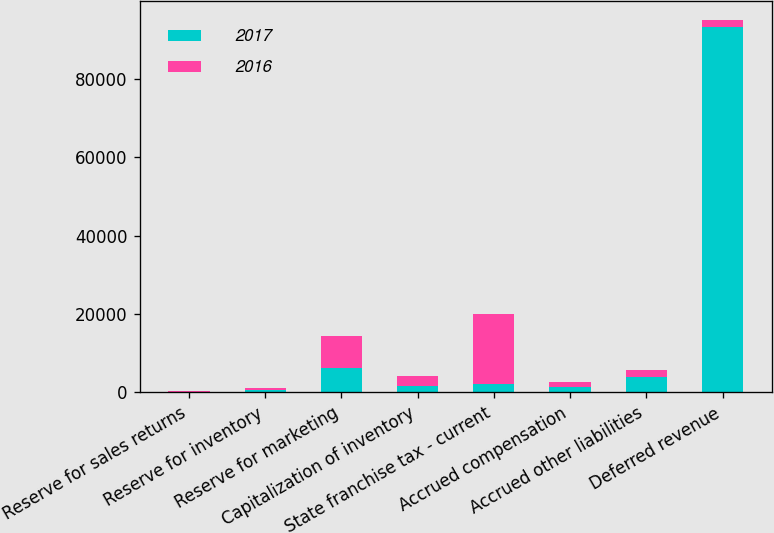Convert chart. <chart><loc_0><loc_0><loc_500><loc_500><stacked_bar_chart><ecel><fcel>Reserve for sales returns<fcel>Reserve for inventory<fcel>Reserve for marketing<fcel>Capitalization of inventory<fcel>State franchise tax - current<fcel>Accrued compensation<fcel>Accrued other liabilities<fcel>Deferred revenue<nl><fcel>2017<fcel>159<fcel>522<fcel>6360<fcel>1598<fcel>2050<fcel>1473<fcel>3917<fcel>93321<nl><fcel>2016<fcel>149<fcel>524<fcel>8065<fcel>2714<fcel>18016<fcel>1212<fcel>1817<fcel>1817<nl></chart> 